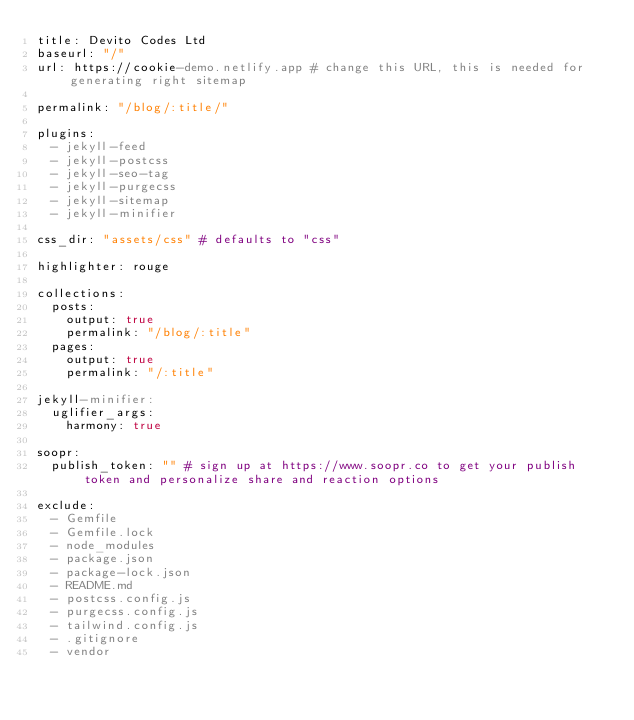Convert code to text. <code><loc_0><loc_0><loc_500><loc_500><_YAML_>title: Devito Codes Ltd
baseurl: "/"
url: https://cookie-demo.netlify.app # change this URL, this is needed for generating right sitemap

permalink: "/blog/:title/"

plugins:
  - jekyll-feed
  - jekyll-postcss
  - jekyll-seo-tag
  - jekyll-purgecss
  - jekyll-sitemap
  - jekyll-minifier

css_dir: "assets/css" # defaults to "css"

highlighter: rouge

collections:
  posts:
    output: true
    permalink: "/blog/:title"
  pages:
    output: true
    permalink: "/:title"

jekyll-minifier:
  uglifier_args:
    harmony: true

soopr:
  publish_token: "" # sign up at https://www.soopr.co to get your publish token and personalize share and reaction options

exclude:
  - Gemfile
  - Gemfile.lock
  - node_modules
  - package.json
  - package-lock.json
  - README.md
  - postcss.config.js
  - purgecss.config.js
  - tailwind.config.js
  - .gitignore
  - vendor
</code> 